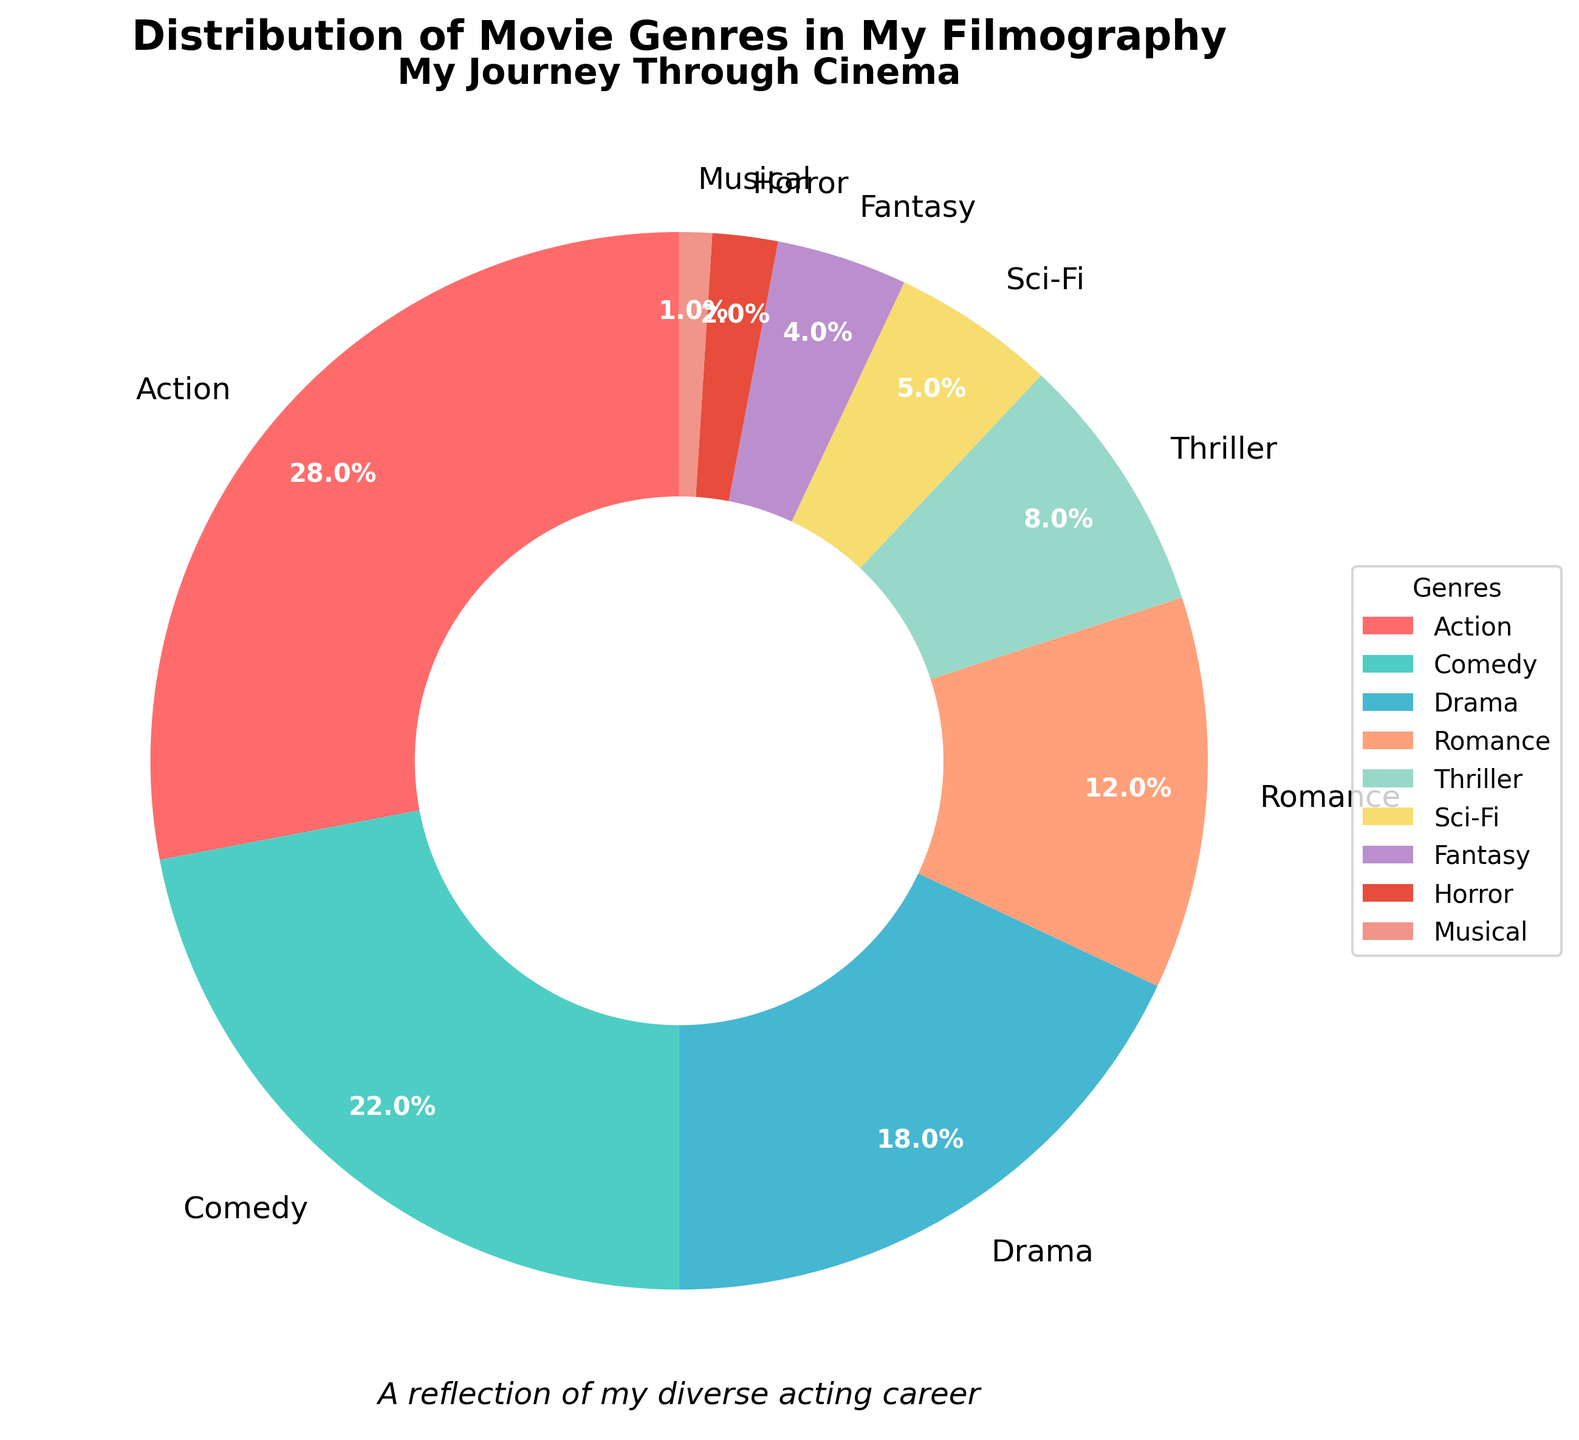What's the most represented movie genre in your filmography? The pie chart indicates that the Action genre occupies the largest slice with 28% of the total.
Answer: Action How much more prominent is the Comedy genre compared to the Sci-Fi genre in your filmography? The percentage for Comedy is 22% and for Sci-Fi is 5%. Subtracting the two gives 22% - 5% = 17%.
Answer: 17% If you combine the percentages of the Drama, Romance, and Thriller genres, what is their total representation? Drama has 18%, Romance has 12%, and Thriller has 8%. Adding them together: 18% + 12% + 8% = 38%.
Answer: 38% Which genre has the smallest representation, and what percentage does it hold? The smallest slice on the chart is for the Musical genre, holding 1%.
Answer: Musical, 1% Is the combined percentage of Action and Comedy genres greater than 50% of your filmography? The percentage for Action is 28% and for Comedy is 22%. Adding them together gives 28% + 22% = 50%. Therefore, the combined percentage is exactly 50%.
Answer: No What is the difference in percentage between the Romance and Horror genres? The percentage for Romance is 12% and for Horror is 2%. The difference is calculated as 12% - 2% = 10%.
Answer: 10% How do the Sci-Fi and Fantasy genres compare in terms of their representation in your filmography? The Sci-Fi genre represents 5%, while the Fantasy genre represents 4%. Sci-Fi holds a slightly larger percentage.
Answer: Sci-Fi > Fantasy If we group the genres into 'Comedy & Lighthearted' (Comedy, Fantasy, Musical) and 'Serious & Intense' (Action, Drama, Thriller, Horror), which group has a higher percentage? 'Comedy & Lighthearted' includes Comedy (22%), Fantasy (4%), and Musical (1%) totaling 22% + 4% + 1% = 27%. 'Serious & Intense' includes Action (28%), Drama (18%), Thriller (8%), and Horror (2%) totaling 28% + 18% + 8% + 2% = 56%. 'Serious & Intense' has a higher percentage.
Answer: Serious & Intense What percentage of your filmography do genres other than the top three (Action, Comedy, Drama) account for? The top three genres sum up to 28% (Action) + 22% (Comedy) + 18% (Drama) = 68%. The remaining percentage is 100% - 68% = 32%.
Answer: 32% How many genres have a percentage representation less than 10%? The genres under 10% are Thriller (8%), Sci-Fi (5%), Fantasy (4%), Horror (2%), and Musical (1%), totaling 5 genres.
Answer: 5 genres 